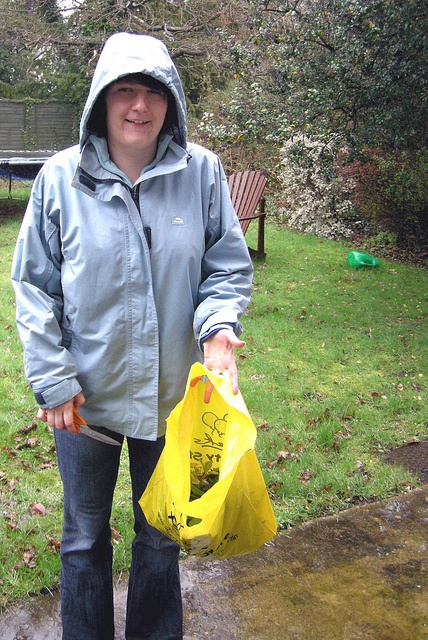Describe the objects in this image and their specific colors. I can see people in gray, black, white, and darkgray tones, chair in gray, lightpink, black, olive, and darkgray tones, and scissors in gray and brown tones in this image. 